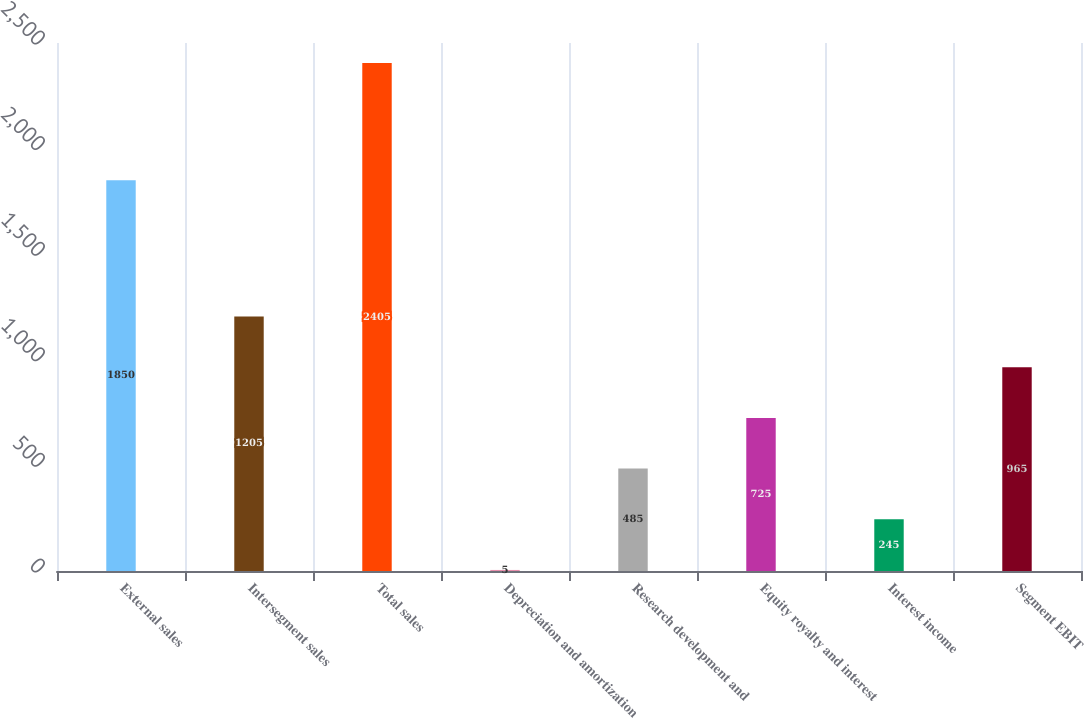Convert chart. <chart><loc_0><loc_0><loc_500><loc_500><bar_chart><fcel>External sales<fcel>Intersegment sales<fcel>Total sales<fcel>Depreciation and amortization<fcel>Research development and<fcel>Equity royalty and interest<fcel>Interest income<fcel>Segment EBIT<nl><fcel>1850<fcel>1205<fcel>2405<fcel>5<fcel>485<fcel>725<fcel>245<fcel>965<nl></chart> 